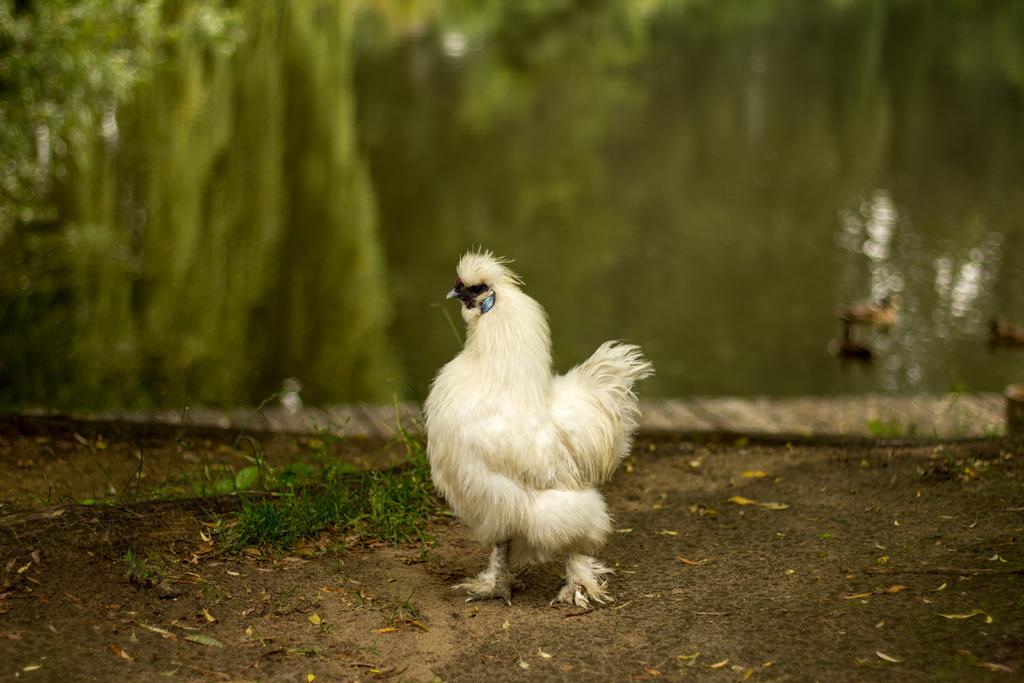In one or two sentences, can you explain what this image depicts? In this image we can see a hen. On the ground there is grass. In the background there is water. 